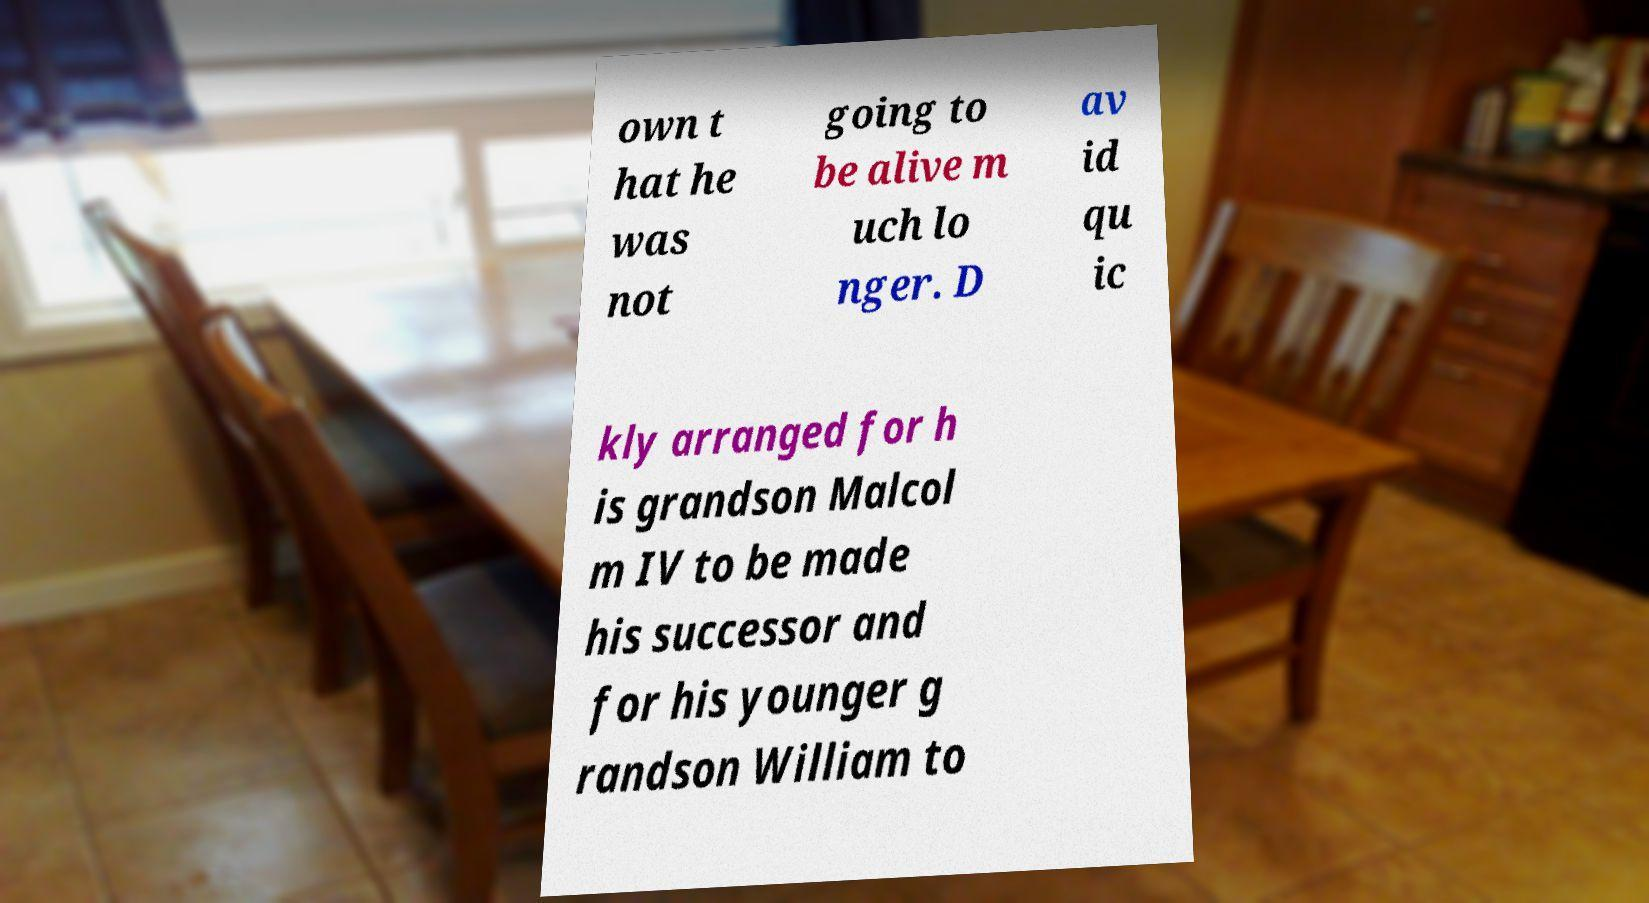Please identify and transcribe the text found in this image. own t hat he was not going to be alive m uch lo nger. D av id qu ic kly arranged for h is grandson Malcol m IV to be made his successor and for his younger g randson William to 